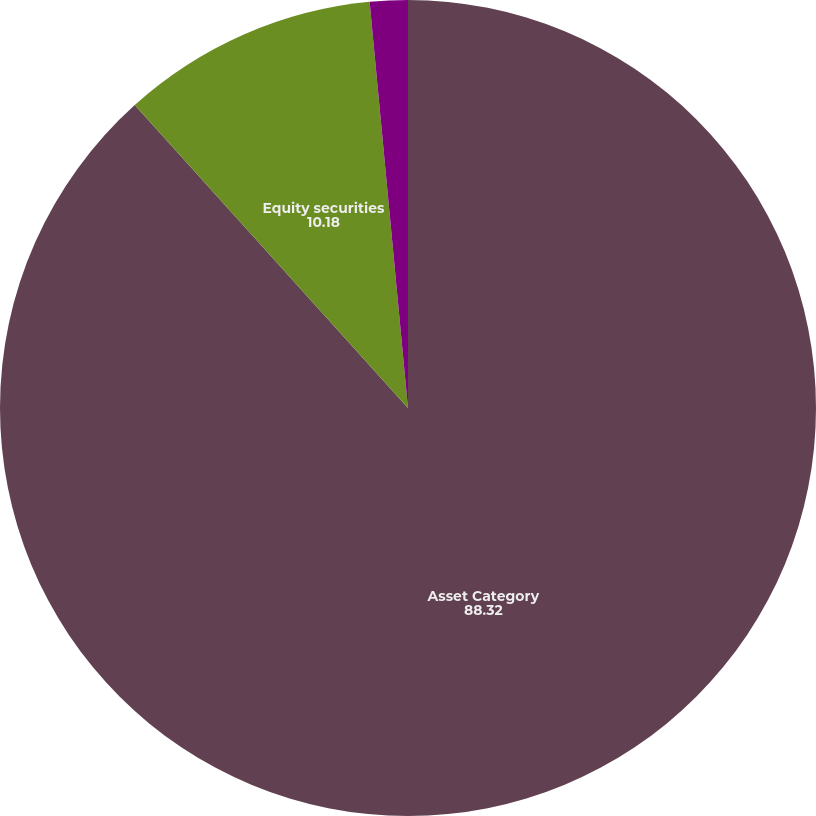Convert chart to OTSL. <chart><loc_0><loc_0><loc_500><loc_500><pie_chart><fcel>Asset Category<fcel>Equity securities<fcel>Debt securities<nl><fcel>88.32%<fcel>10.18%<fcel>1.5%<nl></chart> 